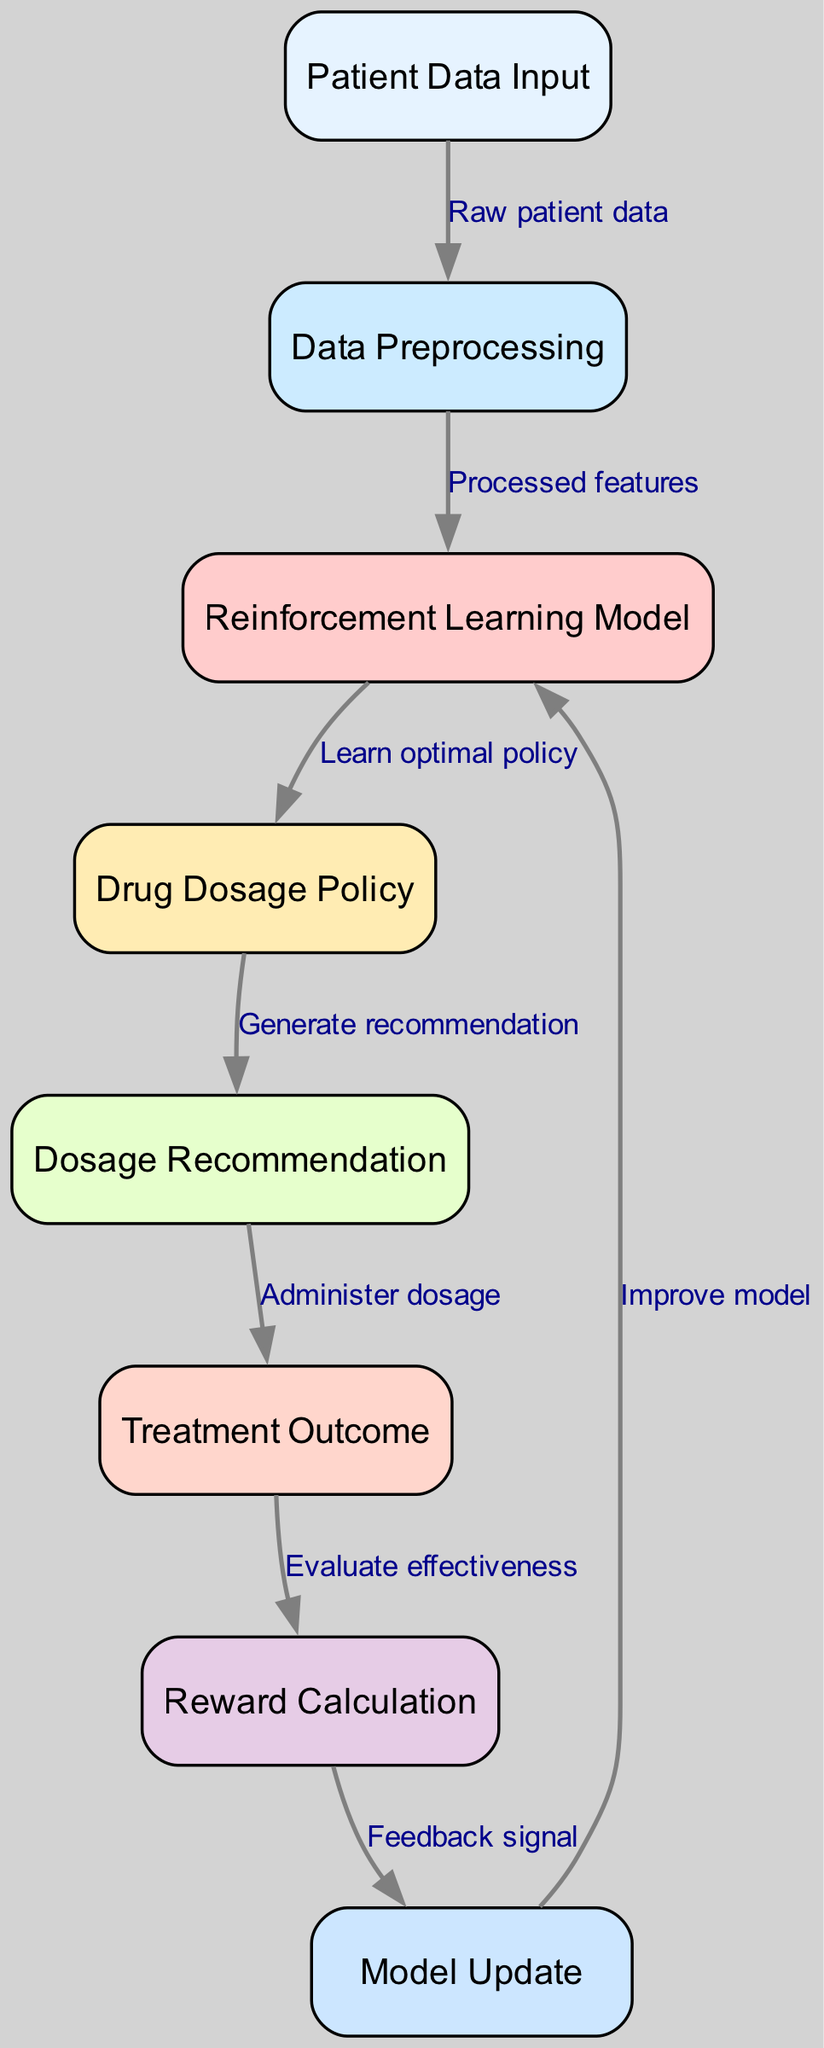What is the first node in the diagram? The first node is labeled "Patient Data Input," as it is the starting point where the process begins. This is visually indicated at the top of the diagram.
Answer: Patient Data Input How many nodes are in the diagram? By counting all the nodes listed in the "nodes" section of the data, we find there are eight nodes present in total.
Answer: Eight What type of learning model is shown in the diagram? The diagram specifically depicts a "Reinforcement Learning Model," which is indicated in the labeling of one of the nodes.
Answer: Reinforcement Learning Model What is the output of the "Dosage Recommendation" node? The "Dosage Recommendation" node outputs the action that is derived from the "Drug Dosage Policy" node. This means it recommends a specific dosage based on the learned policy.
Answer: Dosage Recommendation What is the relationship between the "Treatment Outcome" and "Reward Calculation" nodes? The "Treatment Outcome" node provides a necessary metric for the "Reward Calculation" node which evaluates the effectiveness of the administered dosage and gives feedback.
Answer: Evaluate effectiveness What triggers the "Model Update" process in the diagram? Feedback from the "Reward Calculation" node signals the "Model Update" process, indicating that the model should adjust based on the effectiveness results.
Answer: Feedback signal Which node follows the "Data Preprocessing" node? The node that follows "Data Preprocessing" is the "Reinforcement Learning Model," indicating the processed features are fed into the RL model for further learning.
Answer: Reinforcement Learning Model How does the diagram evaluate treatment effectiveness? Treatment effectiveness is evaluated by the "Reward Calculation," which takes its input from the "Treatment Outcome" node and helps optimize future dosage recommendations.
Answer: Evaluate effectiveness 